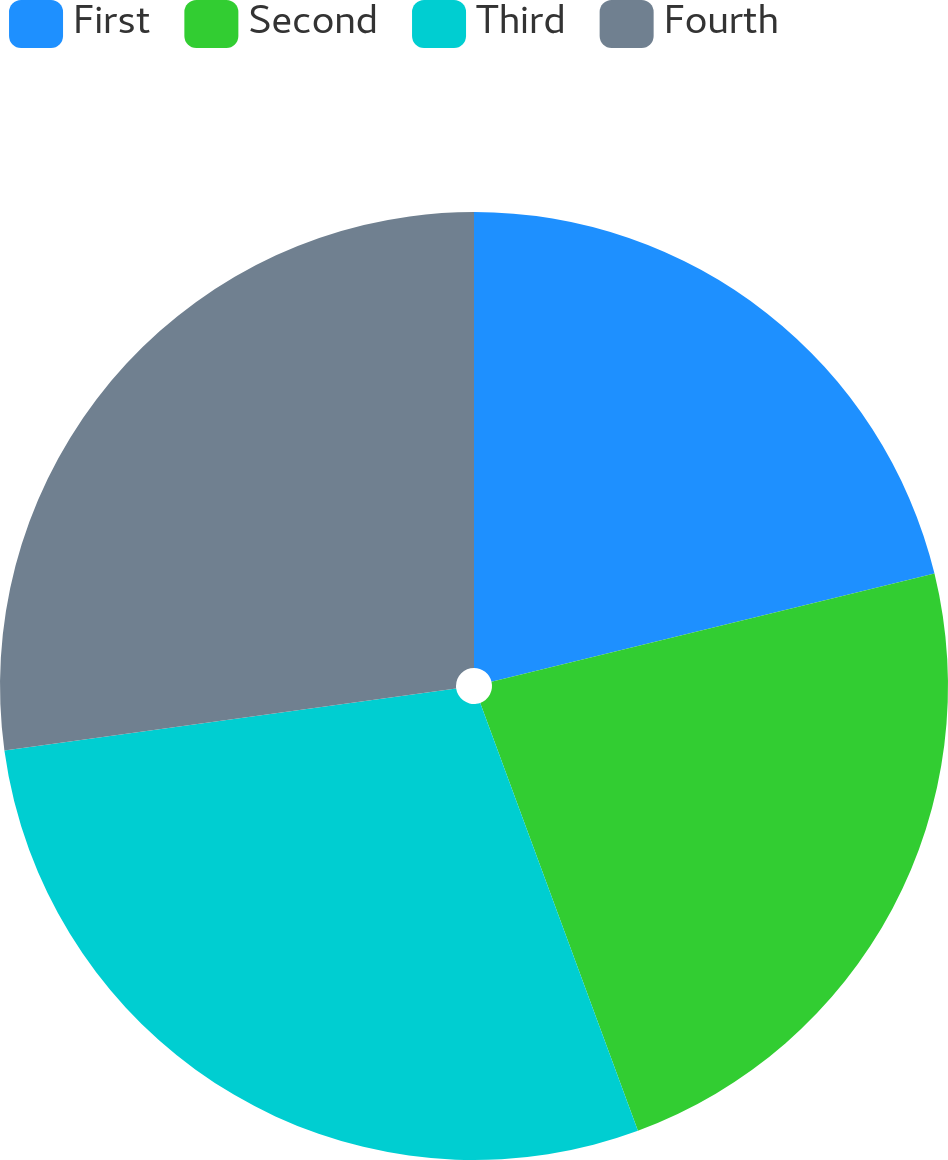Convert chart. <chart><loc_0><loc_0><loc_500><loc_500><pie_chart><fcel>First<fcel>Second<fcel>Third<fcel>Fourth<nl><fcel>21.19%<fcel>23.19%<fcel>28.45%<fcel>27.17%<nl></chart> 